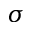Convert formula to latex. <formula><loc_0><loc_0><loc_500><loc_500>\sigma</formula> 